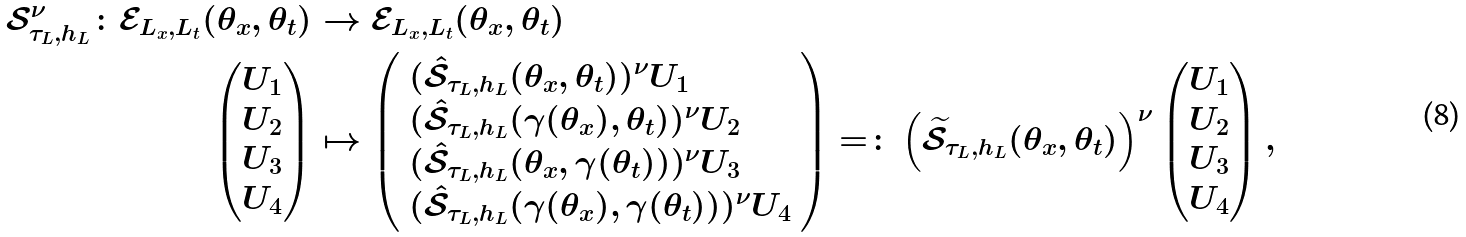<formula> <loc_0><loc_0><loc_500><loc_500>\mathcal { S } _ { \tau _ { L } , h _ { L } } ^ { \nu } \colon \mathcal { E } _ { L _ { x } , L _ { t } } ( \theta _ { x } , \theta _ { t } ) & \rightarrow \mathcal { E } _ { L _ { x } , L _ { t } } ( \theta _ { x } , \theta _ { t } ) \\ \begin{pmatrix} U _ { 1 } \\ U _ { 2 } \\ U _ { 3 } \\ U _ { 4 } \end{pmatrix} & \mapsto \left ( \begin{array} { l } ( \hat { \mathcal { S } } _ { \tau _ { L } , h _ { L } } ( \theta _ { x } , \theta _ { t } ) ) ^ { \nu } U _ { 1 } \\ ( \hat { \mathcal { S } } _ { \tau _ { L } , h _ { L } } ( \gamma ( \theta _ { x } ) , \theta _ { t } ) ) ^ { \nu } U _ { 2 } \\ ( \hat { \mathcal { S } } _ { \tau _ { L } , h _ { L } } ( \theta _ { x } , \gamma ( \theta _ { t } ) ) ) ^ { \nu } U _ { 3 } \\ ( \hat { \mathcal { S } } _ { \tau _ { L } , h _ { L } } ( \gamma ( \theta _ { x } ) , \gamma ( \theta _ { t } ) ) ) ^ { \nu } U _ { 4 } \end{array} \right ) = \colon \left ( \widetilde { \mathcal { S } } _ { \tau _ { L } , h _ { L } } ( \theta _ { x } , \theta _ { t } ) \right ) ^ { \nu } \begin{pmatrix} U _ { 1 } \\ U _ { 2 } \\ U _ { 3 } \\ U _ { 4 } \end{pmatrix} ,</formula> 